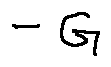Convert formula to latex. <formula><loc_0><loc_0><loc_500><loc_500>- G</formula> 